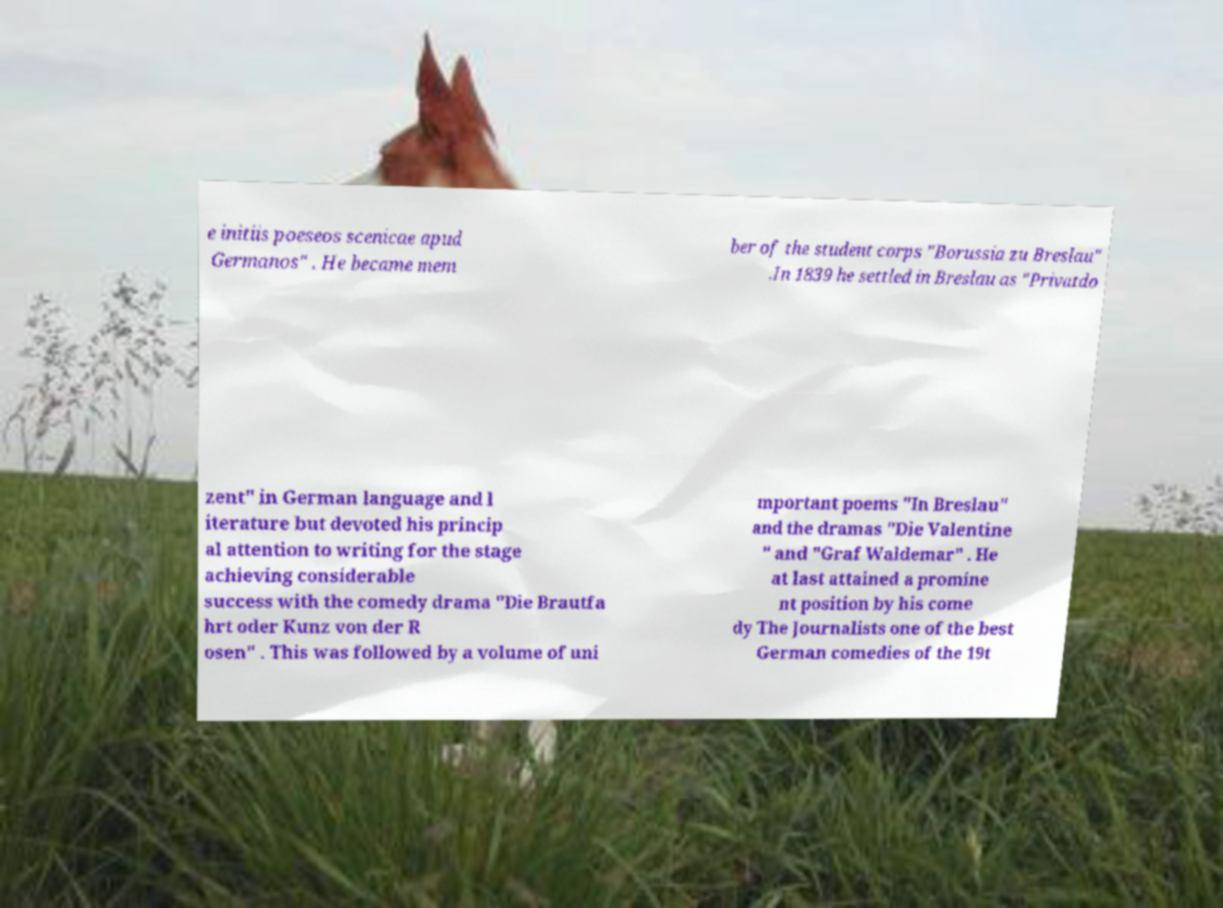Can you read and provide the text displayed in the image?This photo seems to have some interesting text. Can you extract and type it out for me? e initiis poeseos scenicae apud Germanos" . He became mem ber of the student corps "Borussia zu Breslau" .In 1839 he settled in Breslau as "Privatdo zent" in German language and l iterature but devoted his princip al attention to writing for the stage achieving considerable success with the comedy drama "Die Brautfa hrt oder Kunz von der R osen" . This was followed by a volume of uni mportant poems "In Breslau" and the dramas "Die Valentine " and "Graf Waldemar" . He at last attained a promine nt position by his come dy The Journalists one of the best German comedies of the 19t 